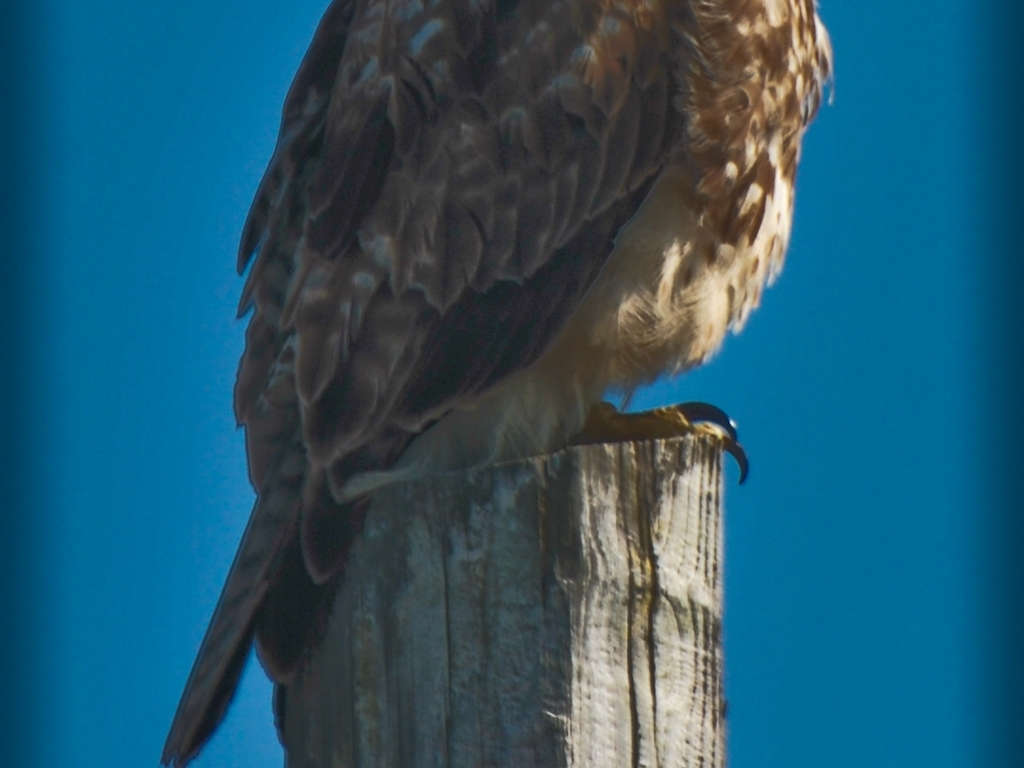Can you describe the environment in which the bird is found? The bird is perched on a wooden post, which suggests a setting that could be rural or semi-rural. The clear blue sky in the background indicates fair weather, likely making it an optimal time for the bird to engage in activities such as hunting. Does the positioning of the bird tell us anything about its behavior? Birds of prey often utilize high perches to gain a vantage point, from which they can survey their surroundings for potential prey. The bird's elevated position on the post could be strategic, maximizing visibility and range of sight. 